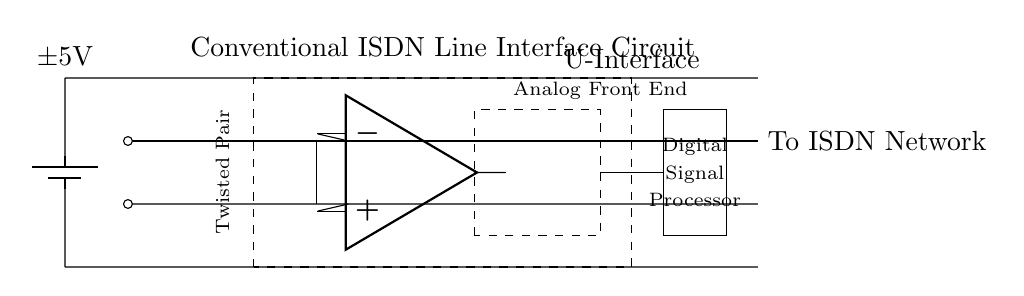What type of power supply is shown in the circuit? The circuit is powered by a battery, specifically a dual power supply noted as plus and minus 5 volts. This can be seen at the left side of the circuit where the battery symbol is used.
Answer: Battery What is the role of the transformer in this circuit? The transformer is used to couple the line signals to the U-interface. It is essential in managing the impedance and signal integrity for ISDN lines. The location between the twisted pair and the operational amplifier indicates its function within the circuit.
Answer: Coupling How many components are encapsulated in the U-Interface? The U-interface box contains two main components: the line driver (operational amplifier) and the analog front end, effectively wiring them together for digital signal processing. The dashed box visibly signals the encapsulation area in the circuit.
Answer: Two What is the purpose of the operational amplifier in the circuit? The operational amplifier acts as a line driver, amplifying the signals from the twisted pair and facilitating the conversion of analog signals into a suitable form for further processing in the digital signal processor. It connects the incoming signal directly to the analog front end.
Answer: Amplifying What type of signal processing is indicated in the DSP section? The digital signal processor section is designated for processing digital signals, which is essential in the context of ISDN technology that relies on converting analog data into digital form for communication over the network. The labeling in the rectangle indicates this function.
Answer: Digital What does the dashed rectangle surrounding the Analog Front End indicate? The dashed rectangle signifies that the Analog Front End component is a defined section of the circuit responsible for preparing analog signals before they are sent to the DSP for digitization. This structural indication points to its integrative role within the interface.
Answer: Preparation 